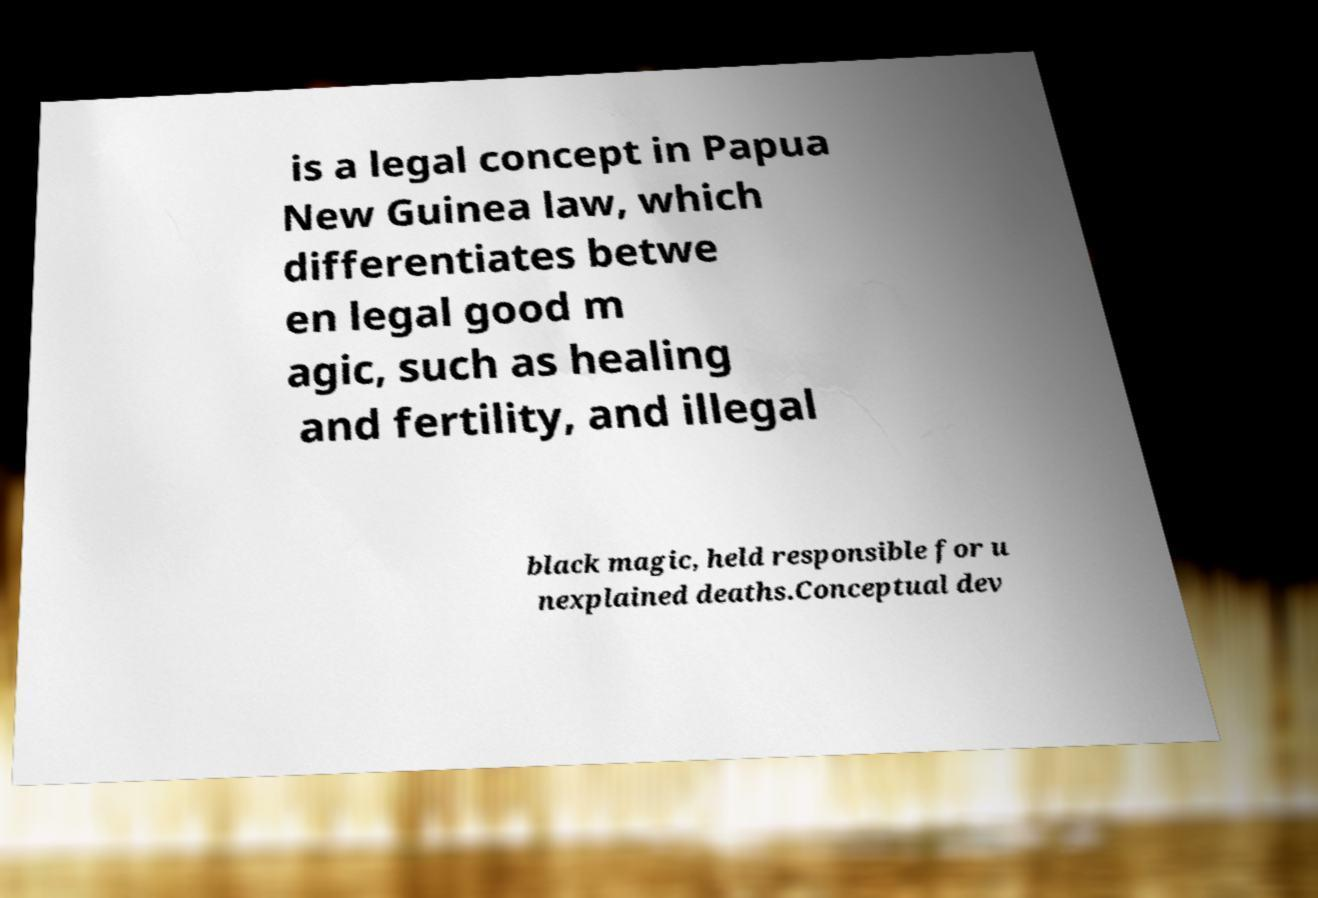Could you assist in decoding the text presented in this image and type it out clearly? is a legal concept in Papua New Guinea law, which differentiates betwe en legal good m agic, such as healing and fertility, and illegal black magic, held responsible for u nexplained deaths.Conceptual dev 